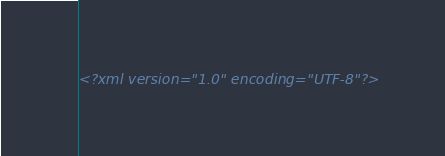<code> <loc_0><loc_0><loc_500><loc_500><_XML_><?xml version="1.0" encoding="UTF-8"?></code> 